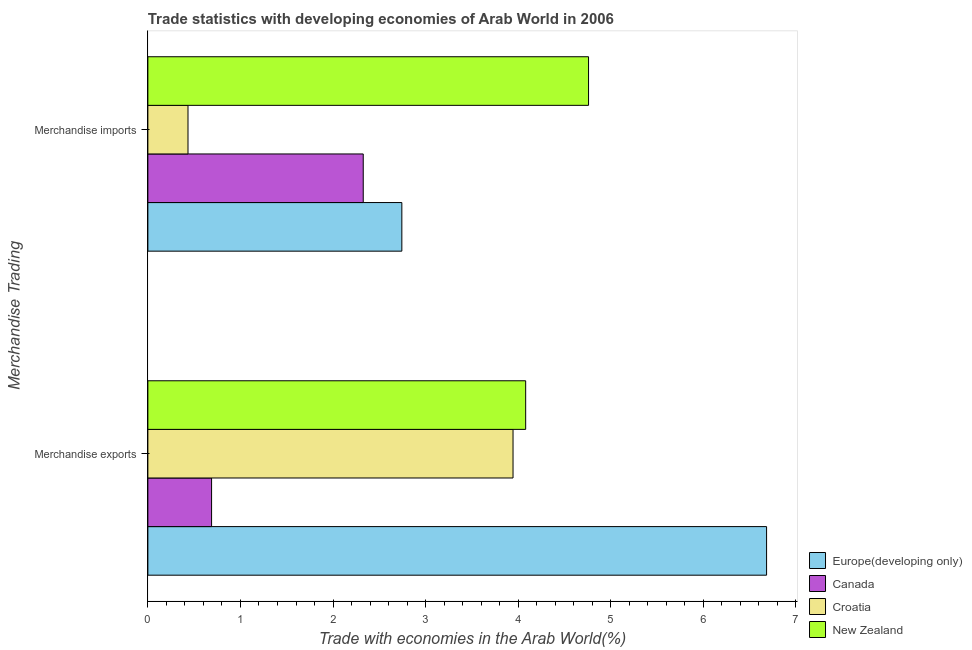Are the number of bars per tick equal to the number of legend labels?
Make the answer very short. Yes. What is the merchandise imports in Canada?
Keep it short and to the point. 2.33. Across all countries, what is the maximum merchandise imports?
Your answer should be very brief. 4.76. Across all countries, what is the minimum merchandise imports?
Provide a succinct answer. 0.43. In which country was the merchandise exports maximum?
Give a very brief answer. Europe(developing only). What is the total merchandise exports in the graph?
Your answer should be very brief. 15.4. What is the difference between the merchandise imports in Europe(developing only) and that in Canada?
Offer a terse response. 0.42. What is the difference between the merchandise exports in Europe(developing only) and the merchandise imports in Croatia?
Keep it short and to the point. 6.25. What is the average merchandise imports per country?
Give a very brief answer. 2.57. What is the difference between the merchandise imports and merchandise exports in Canada?
Provide a succinct answer. 1.64. In how many countries, is the merchandise exports greater than 3.8 %?
Your answer should be compact. 3. What is the ratio of the merchandise imports in Canada to that in New Zealand?
Provide a succinct answer. 0.49. Is the merchandise imports in Europe(developing only) less than that in Croatia?
Your answer should be very brief. No. What does the 1st bar from the bottom in Merchandise exports represents?
Ensure brevity in your answer.  Europe(developing only). Are all the bars in the graph horizontal?
Give a very brief answer. Yes. Does the graph contain any zero values?
Your response must be concise. No. Does the graph contain grids?
Your answer should be very brief. No. Where does the legend appear in the graph?
Keep it short and to the point. Bottom right. How are the legend labels stacked?
Give a very brief answer. Vertical. What is the title of the graph?
Ensure brevity in your answer.  Trade statistics with developing economies of Arab World in 2006. What is the label or title of the X-axis?
Provide a short and direct response. Trade with economies in the Arab World(%). What is the label or title of the Y-axis?
Provide a succinct answer. Merchandise Trading. What is the Trade with economies in the Arab World(%) of Europe(developing only) in Merchandise exports?
Give a very brief answer. 6.68. What is the Trade with economies in the Arab World(%) in Canada in Merchandise exports?
Your answer should be very brief. 0.69. What is the Trade with economies in the Arab World(%) of Croatia in Merchandise exports?
Make the answer very short. 3.94. What is the Trade with economies in the Arab World(%) of New Zealand in Merchandise exports?
Keep it short and to the point. 4.08. What is the Trade with economies in the Arab World(%) in Europe(developing only) in Merchandise imports?
Give a very brief answer. 2.74. What is the Trade with economies in the Arab World(%) of Canada in Merchandise imports?
Keep it short and to the point. 2.33. What is the Trade with economies in the Arab World(%) in Croatia in Merchandise imports?
Provide a succinct answer. 0.43. What is the Trade with economies in the Arab World(%) in New Zealand in Merchandise imports?
Ensure brevity in your answer.  4.76. Across all Merchandise Trading, what is the maximum Trade with economies in the Arab World(%) of Europe(developing only)?
Your answer should be very brief. 6.68. Across all Merchandise Trading, what is the maximum Trade with economies in the Arab World(%) of Canada?
Provide a short and direct response. 2.33. Across all Merchandise Trading, what is the maximum Trade with economies in the Arab World(%) in Croatia?
Keep it short and to the point. 3.94. Across all Merchandise Trading, what is the maximum Trade with economies in the Arab World(%) in New Zealand?
Your response must be concise. 4.76. Across all Merchandise Trading, what is the minimum Trade with economies in the Arab World(%) of Europe(developing only)?
Make the answer very short. 2.74. Across all Merchandise Trading, what is the minimum Trade with economies in the Arab World(%) in Canada?
Keep it short and to the point. 0.69. Across all Merchandise Trading, what is the minimum Trade with economies in the Arab World(%) of Croatia?
Provide a succinct answer. 0.43. Across all Merchandise Trading, what is the minimum Trade with economies in the Arab World(%) of New Zealand?
Your response must be concise. 4.08. What is the total Trade with economies in the Arab World(%) of Europe(developing only) in the graph?
Provide a short and direct response. 9.43. What is the total Trade with economies in the Arab World(%) of Canada in the graph?
Offer a terse response. 3.01. What is the total Trade with economies in the Arab World(%) in Croatia in the graph?
Give a very brief answer. 4.38. What is the total Trade with economies in the Arab World(%) of New Zealand in the graph?
Provide a succinct answer. 8.84. What is the difference between the Trade with economies in the Arab World(%) in Europe(developing only) in Merchandise exports and that in Merchandise imports?
Ensure brevity in your answer.  3.94. What is the difference between the Trade with economies in the Arab World(%) in Canada in Merchandise exports and that in Merchandise imports?
Your answer should be very brief. -1.64. What is the difference between the Trade with economies in the Arab World(%) in Croatia in Merchandise exports and that in Merchandise imports?
Make the answer very short. 3.51. What is the difference between the Trade with economies in the Arab World(%) of New Zealand in Merchandise exports and that in Merchandise imports?
Provide a short and direct response. -0.68. What is the difference between the Trade with economies in the Arab World(%) in Europe(developing only) in Merchandise exports and the Trade with economies in the Arab World(%) in Canada in Merchandise imports?
Keep it short and to the point. 4.36. What is the difference between the Trade with economies in the Arab World(%) in Europe(developing only) in Merchandise exports and the Trade with economies in the Arab World(%) in Croatia in Merchandise imports?
Offer a very short reply. 6.25. What is the difference between the Trade with economies in the Arab World(%) in Europe(developing only) in Merchandise exports and the Trade with economies in the Arab World(%) in New Zealand in Merchandise imports?
Give a very brief answer. 1.92. What is the difference between the Trade with economies in the Arab World(%) of Canada in Merchandise exports and the Trade with economies in the Arab World(%) of Croatia in Merchandise imports?
Offer a very short reply. 0.25. What is the difference between the Trade with economies in the Arab World(%) in Canada in Merchandise exports and the Trade with economies in the Arab World(%) in New Zealand in Merchandise imports?
Ensure brevity in your answer.  -4.07. What is the difference between the Trade with economies in the Arab World(%) of Croatia in Merchandise exports and the Trade with economies in the Arab World(%) of New Zealand in Merchandise imports?
Your answer should be compact. -0.82. What is the average Trade with economies in the Arab World(%) in Europe(developing only) per Merchandise Trading?
Your answer should be very brief. 4.71. What is the average Trade with economies in the Arab World(%) of Canada per Merchandise Trading?
Provide a succinct answer. 1.51. What is the average Trade with economies in the Arab World(%) in Croatia per Merchandise Trading?
Your answer should be compact. 2.19. What is the average Trade with economies in the Arab World(%) in New Zealand per Merchandise Trading?
Offer a terse response. 4.42. What is the difference between the Trade with economies in the Arab World(%) of Europe(developing only) and Trade with economies in the Arab World(%) of Canada in Merchandise exports?
Give a very brief answer. 5.99. What is the difference between the Trade with economies in the Arab World(%) of Europe(developing only) and Trade with economies in the Arab World(%) of Croatia in Merchandise exports?
Your answer should be very brief. 2.74. What is the difference between the Trade with economies in the Arab World(%) of Europe(developing only) and Trade with economies in the Arab World(%) of New Zealand in Merchandise exports?
Give a very brief answer. 2.6. What is the difference between the Trade with economies in the Arab World(%) in Canada and Trade with economies in the Arab World(%) in Croatia in Merchandise exports?
Your answer should be very brief. -3.26. What is the difference between the Trade with economies in the Arab World(%) of Canada and Trade with economies in the Arab World(%) of New Zealand in Merchandise exports?
Your answer should be very brief. -3.39. What is the difference between the Trade with economies in the Arab World(%) of Croatia and Trade with economies in the Arab World(%) of New Zealand in Merchandise exports?
Make the answer very short. -0.14. What is the difference between the Trade with economies in the Arab World(%) of Europe(developing only) and Trade with economies in the Arab World(%) of Canada in Merchandise imports?
Provide a short and direct response. 0.42. What is the difference between the Trade with economies in the Arab World(%) in Europe(developing only) and Trade with economies in the Arab World(%) in Croatia in Merchandise imports?
Offer a terse response. 2.31. What is the difference between the Trade with economies in the Arab World(%) of Europe(developing only) and Trade with economies in the Arab World(%) of New Zealand in Merchandise imports?
Make the answer very short. -2.02. What is the difference between the Trade with economies in the Arab World(%) in Canada and Trade with economies in the Arab World(%) in Croatia in Merchandise imports?
Ensure brevity in your answer.  1.89. What is the difference between the Trade with economies in the Arab World(%) of Canada and Trade with economies in the Arab World(%) of New Zealand in Merchandise imports?
Provide a succinct answer. -2.43. What is the difference between the Trade with economies in the Arab World(%) in Croatia and Trade with economies in the Arab World(%) in New Zealand in Merchandise imports?
Keep it short and to the point. -4.33. What is the ratio of the Trade with economies in the Arab World(%) in Europe(developing only) in Merchandise exports to that in Merchandise imports?
Provide a short and direct response. 2.44. What is the ratio of the Trade with economies in the Arab World(%) of Canada in Merchandise exports to that in Merchandise imports?
Offer a very short reply. 0.3. What is the ratio of the Trade with economies in the Arab World(%) of Croatia in Merchandise exports to that in Merchandise imports?
Give a very brief answer. 9.1. What is the ratio of the Trade with economies in the Arab World(%) in New Zealand in Merchandise exports to that in Merchandise imports?
Your answer should be very brief. 0.86. What is the difference between the highest and the second highest Trade with economies in the Arab World(%) in Europe(developing only)?
Give a very brief answer. 3.94. What is the difference between the highest and the second highest Trade with economies in the Arab World(%) in Canada?
Make the answer very short. 1.64. What is the difference between the highest and the second highest Trade with economies in the Arab World(%) in Croatia?
Offer a terse response. 3.51. What is the difference between the highest and the second highest Trade with economies in the Arab World(%) in New Zealand?
Your response must be concise. 0.68. What is the difference between the highest and the lowest Trade with economies in the Arab World(%) of Europe(developing only)?
Ensure brevity in your answer.  3.94. What is the difference between the highest and the lowest Trade with economies in the Arab World(%) of Canada?
Your answer should be very brief. 1.64. What is the difference between the highest and the lowest Trade with economies in the Arab World(%) of Croatia?
Provide a succinct answer. 3.51. What is the difference between the highest and the lowest Trade with economies in the Arab World(%) in New Zealand?
Your response must be concise. 0.68. 